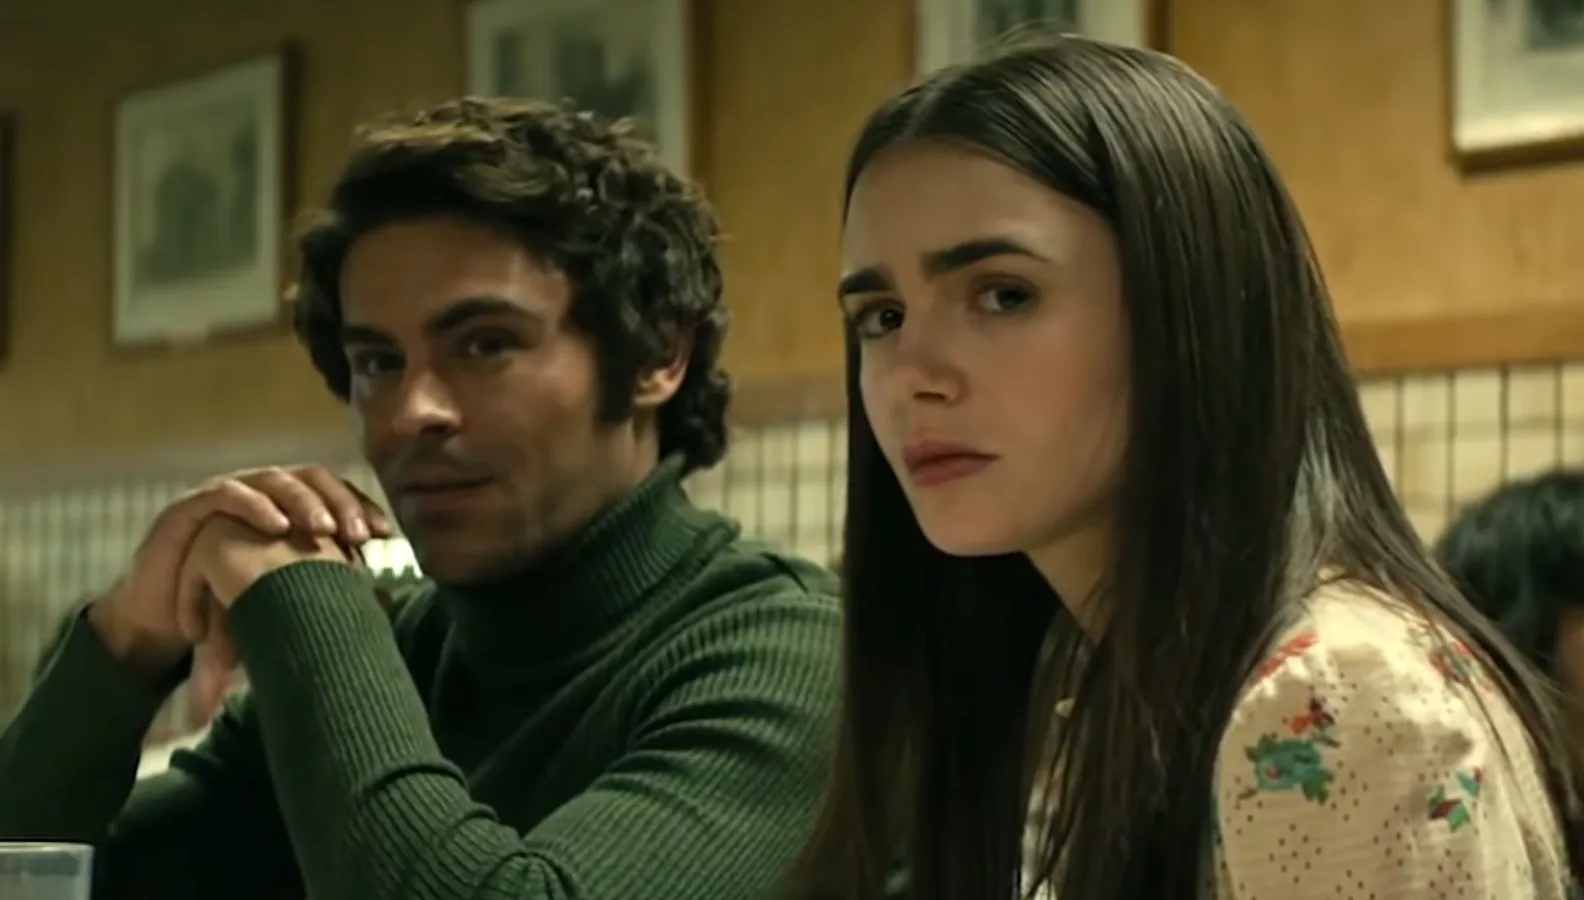Explain the visual content of the image in great detail. In this image, actors Zac Efron and Lily Collins are featured in a scene that appears to be from a movie or TV show, set in a diner. Both are seated in a semi-circular booth against a backdrop of framed pictures and patterned tiles. Zac Efron, on the left, wears a green turtleneck sweater and rests his chin on his hand, exuding a contemplative vibe as he gazes off to the right. Opposite him, Lily Collins is dressed in a white blouse with a vintage floral pattern, and she, too, directs her serious gaze towards the right. The mood of the scene suggests a moment of deep reflection or intense conversation between the two characters, adding a layer of intrigue and gravity to their interaction. 